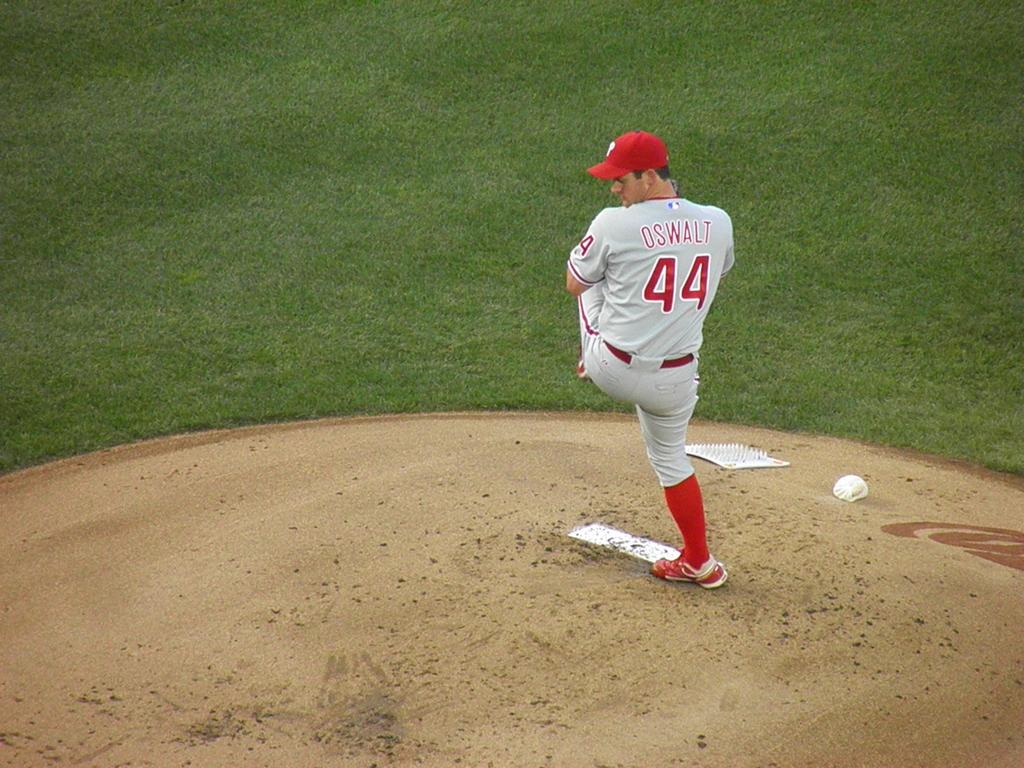<image>
Summarize the visual content of the image. A baseball pitcher with the name Oswalt and number 44 on his jersey. 